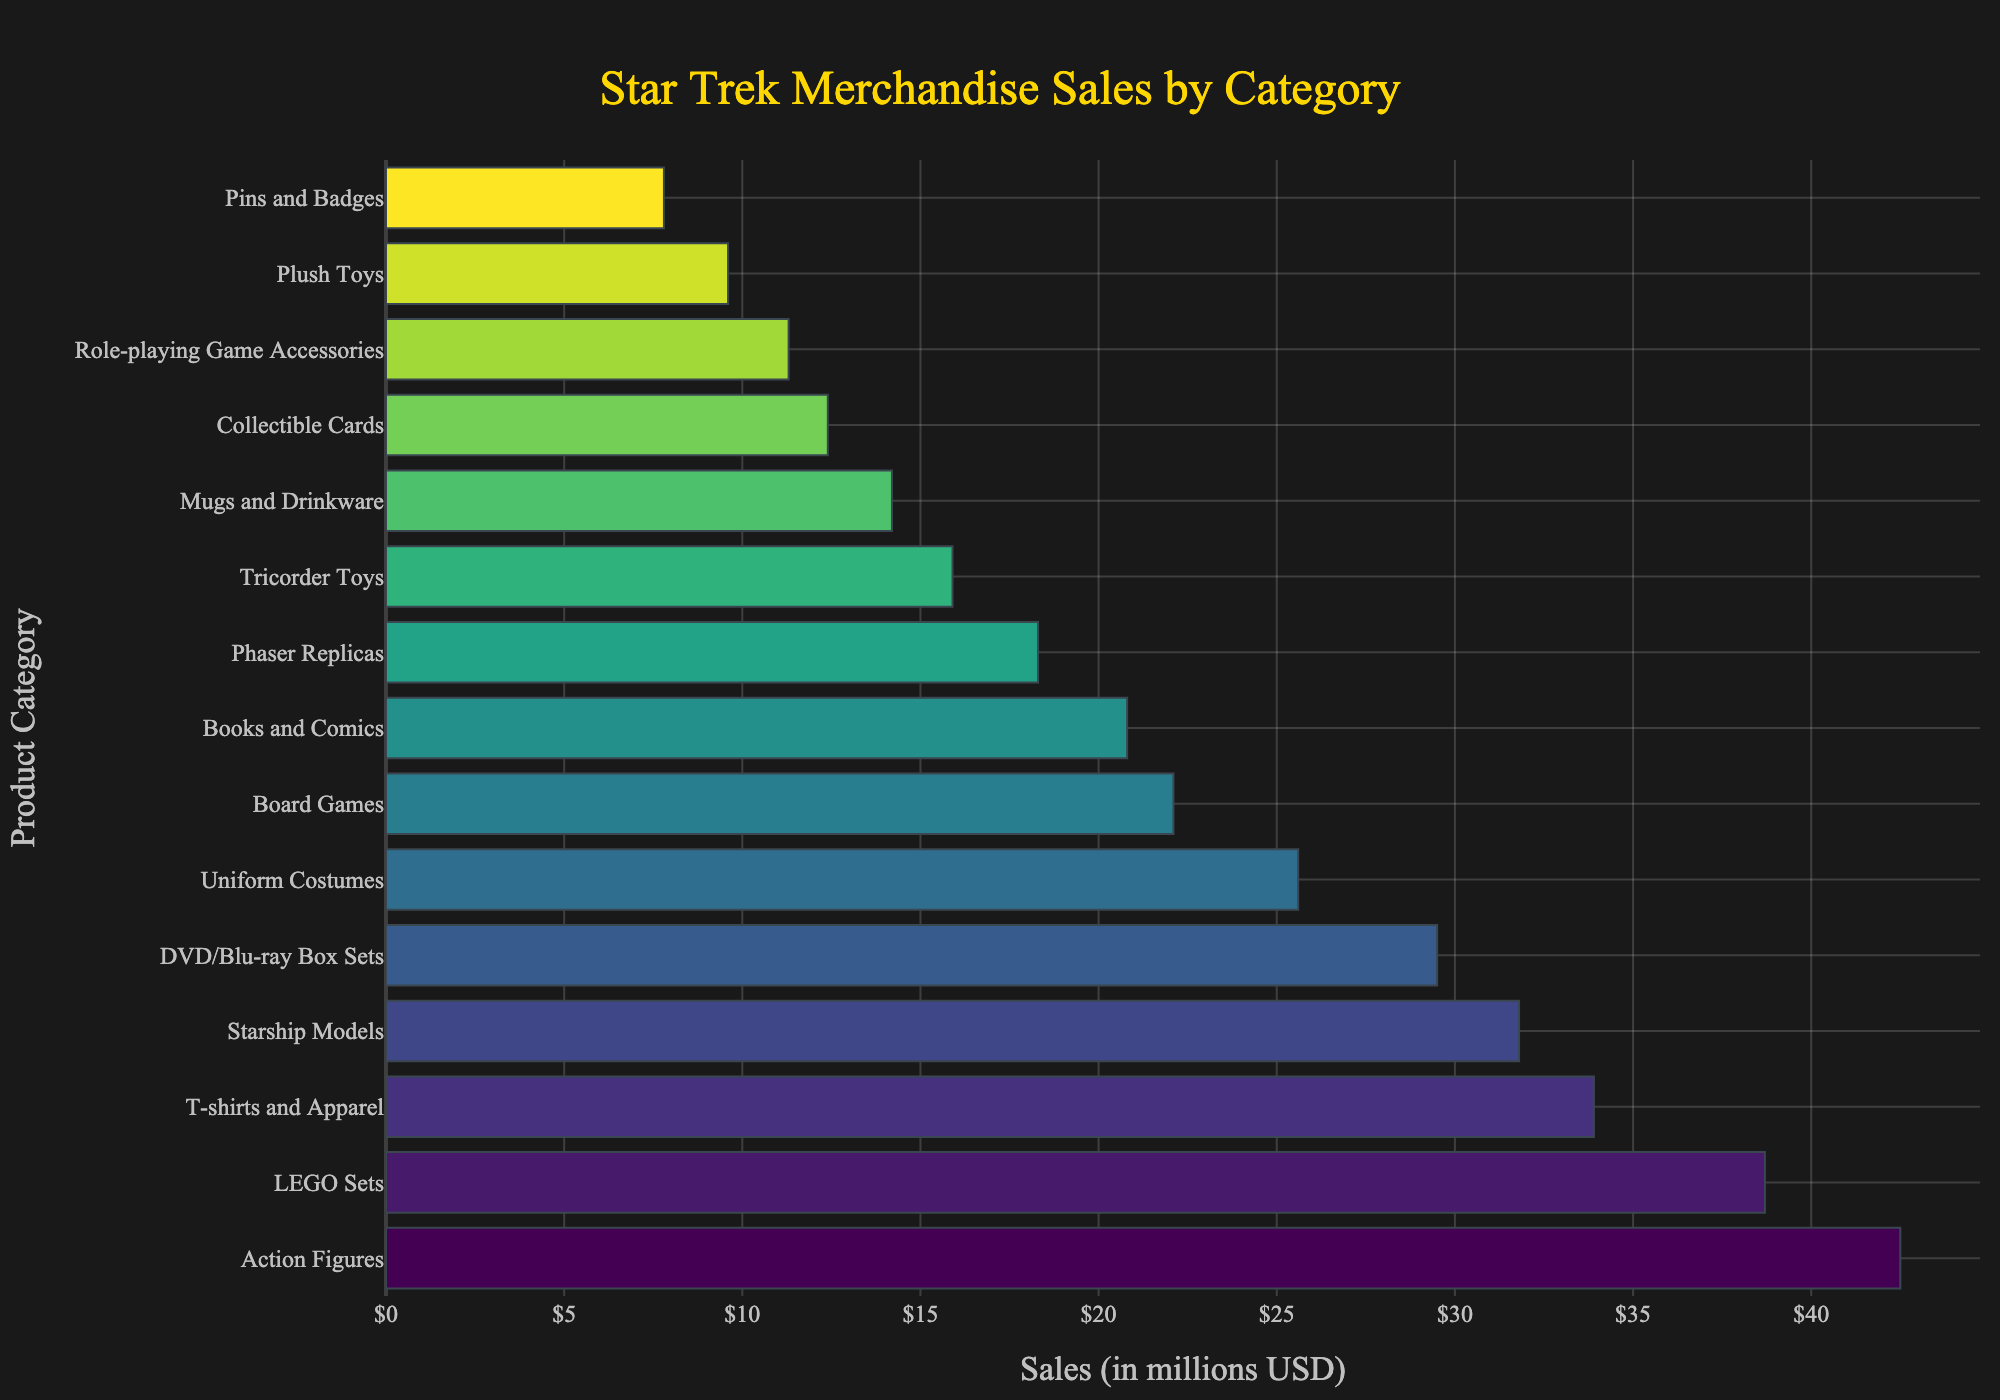Which product category has the highest sales? The highest bar represents the highest sales, which is for "Action Figures" at $42.5 million.
Answer: Action Figures Which two categories have the closest sales amounts? Comparing the bar lengths, "Board Games" ($22.1 million) and "Books and Comics" ($20.8 million) are closest in sales.
Answer: Board Games and Books and Comics How much more do T-shirts and Apparel earn compared to Phaser Replicas? The sales for "T-shirts and Apparel" are $33.9 million and for "Phaser Replicas" are $18.3 million, so the difference is $33.9 million - $18.3 million.
Answer: $15.6 million Which category has the lowest sales? The shortest bar represents the lowest sales, which is for "Pins and Badges" at $7.8 million.
Answer: Pins and Badges What are the total combined sales for Tricorder Toys and Mugs and Drinkware? The sales for "Tricorder Toys" and "Mugs and Drinkware" are $15.9 million and $14.2 million respectively, so the combined sales are $15.9 million + $14.2 million.
Answer: $30.1 million What fraction of the total sales does Starship Models represent? Starship Models sales amount is $31.8 million. To find the fraction, sum all sales: 42.5 + 31.8 + 18.3 + 25.6 + 15.9 + 22.1 + 38.7 + 12.4 + 29.5 + 20.8 + 9.6 + 14.2 + 33.9 + 7.8 + 11.3 = 324.4 million. Then 31.8/324.4 ≈ 0.098.
Answer: About 0.098 Which category sells more: LEGO Sets or DVD/Blu-ray Box Sets? Comparing the bar lengths, "LEGO Sets" (38.7 million) sell more than "DVD/Blu-ray Box Sets" (29.5 million).
Answer: LEGO Sets Rank the top three categories by sales. Based on the bar heights, the top three categories by sales are "Action Figures" (42.5 million), "LEGO Sets" (38.7 million), and "T-shirts and Apparel" (33.9 million).
Answer: Action Figures, LEGO Sets, T-shirts and Apparel What is the difference in sales between the highest and lowest categories? The highest sales are for "Action Figures" ($42.5 million) and the lowest for "Pins and Badges" ($7.8 million). The difference is $42.5 million - $7.8 million.
Answer: $34.7 million 